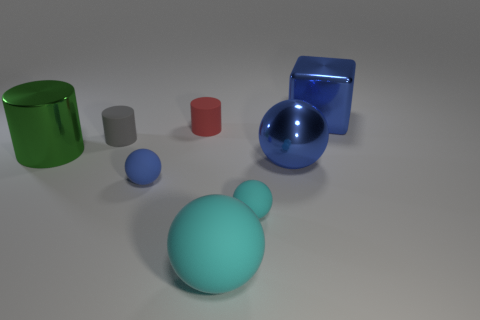Subtract all brown balls. Subtract all purple cylinders. How many balls are left? 4 Add 1 shiny objects. How many objects exist? 9 Subtract all blocks. How many objects are left? 7 Subtract 0 purple cubes. How many objects are left? 8 Subtract all large metal things. Subtract all shiny spheres. How many objects are left? 4 Add 6 small cyan rubber balls. How many small cyan rubber balls are left? 7 Add 3 gray cylinders. How many gray cylinders exist? 4 